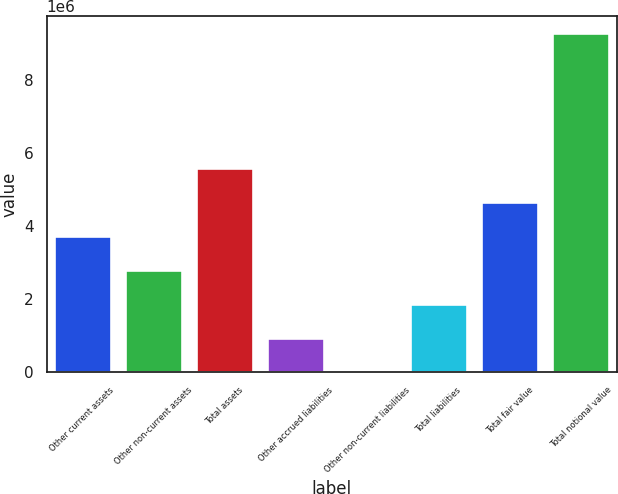Convert chart. <chart><loc_0><loc_0><loc_500><loc_500><bar_chart><fcel>Other current assets<fcel>Other non-current assets<fcel>Total assets<fcel>Other accrued liabilities<fcel>Other non-current liabilities<fcel>Total liabilities<fcel>Total fair value<fcel>Total notional value<nl><fcel>3.72648e+06<fcel>2.79917e+06<fcel>5.5811e+06<fcel>944554<fcel>17244<fcel>1.87186e+06<fcel>4.65379e+06<fcel>9.29034e+06<nl></chart> 